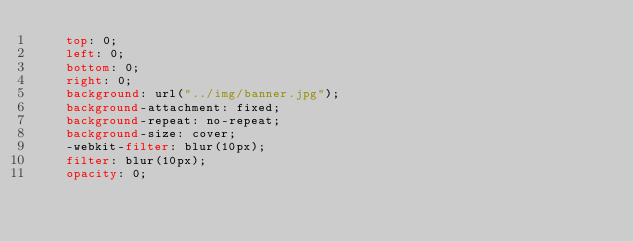Convert code to text. <code><loc_0><loc_0><loc_500><loc_500><_CSS_>    top: 0;
    left: 0;
    bottom: 0;
    right: 0;
    background: url("../img/banner.jpg");
    background-attachment: fixed;
    background-repeat: no-repeat;
    background-size: cover;
    -webkit-filter: blur(10px);
    filter: blur(10px);
    opacity: 0;</code> 